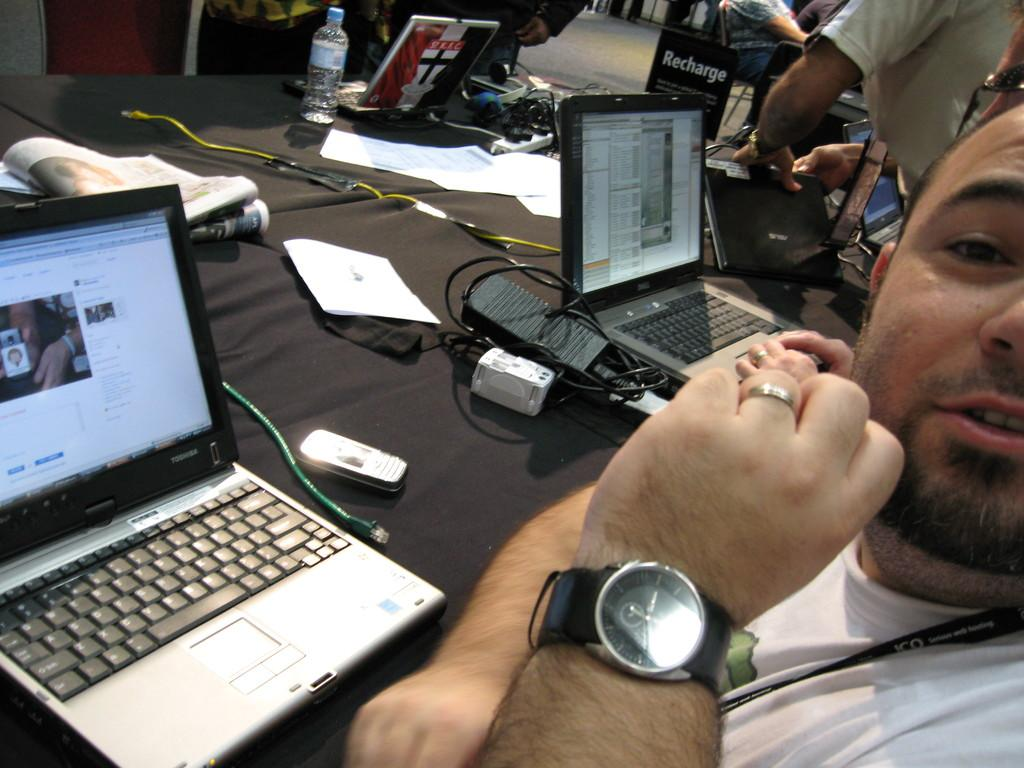<image>
Share a concise interpretation of the image provided. A sits at a table working on a Toshiba laptop. 